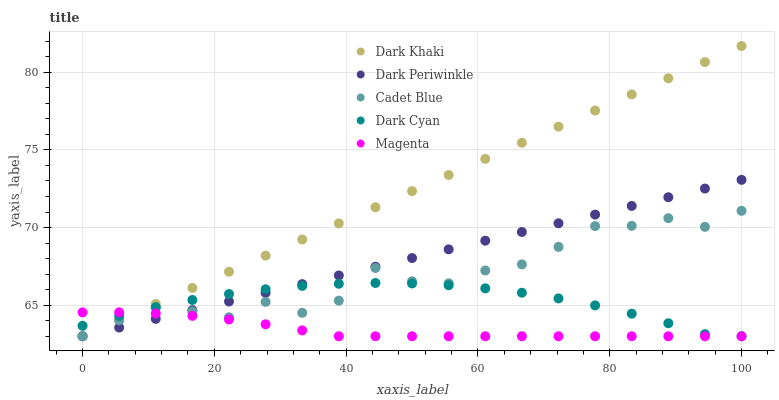Does Magenta have the minimum area under the curve?
Answer yes or no. Yes. Does Dark Khaki have the maximum area under the curve?
Answer yes or no. Yes. Does Dark Cyan have the minimum area under the curve?
Answer yes or no. No. Does Dark Cyan have the maximum area under the curve?
Answer yes or no. No. Is Dark Periwinkle the smoothest?
Answer yes or no. Yes. Is Cadet Blue the roughest?
Answer yes or no. Yes. Is Dark Cyan the smoothest?
Answer yes or no. No. Is Dark Cyan the roughest?
Answer yes or no. No. Does Dark Khaki have the lowest value?
Answer yes or no. Yes. Does Dark Khaki have the highest value?
Answer yes or no. Yes. Does Dark Cyan have the highest value?
Answer yes or no. No. Does Magenta intersect Dark Periwinkle?
Answer yes or no. Yes. Is Magenta less than Dark Periwinkle?
Answer yes or no. No. Is Magenta greater than Dark Periwinkle?
Answer yes or no. No. 